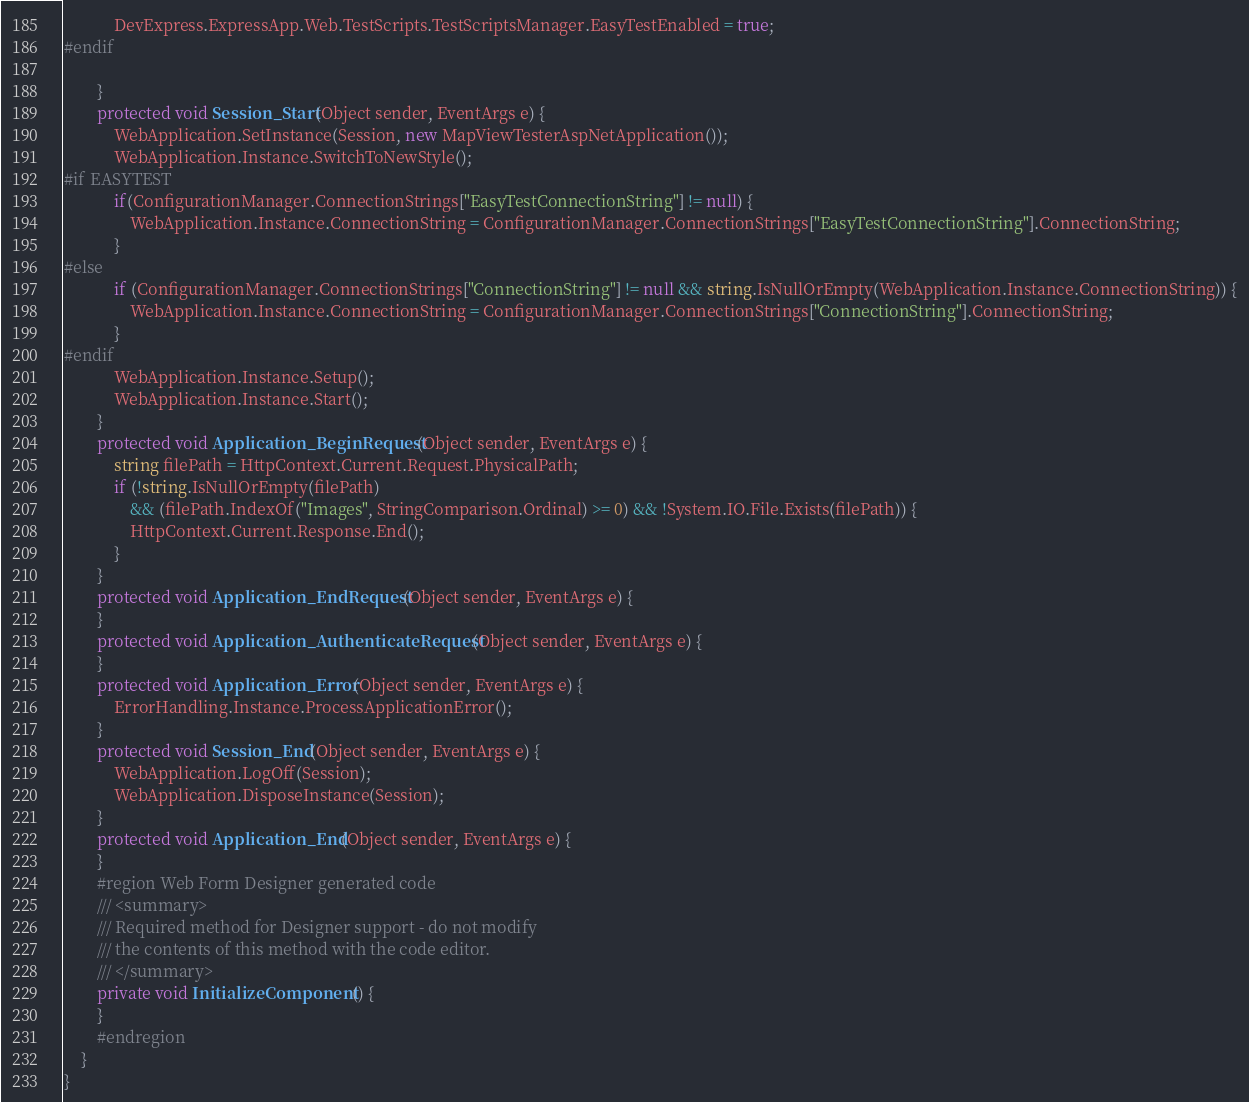<code> <loc_0><loc_0><loc_500><loc_500><_C#_>			DevExpress.ExpressApp.Web.TestScripts.TestScriptsManager.EasyTestEnabled = true;
#endif

        }
        protected void Session_Start(Object sender, EventArgs e) {
            WebApplication.SetInstance(Session, new MapViewTesterAspNetApplication());
            WebApplication.Instance.SwitchToNewStyle();
#if EASYTEST
			if(ConfigurationManager.ConnectionStrings["EasyTestConnectionString"] != null) {
				WebApplication.Instance.ConnectionString = ConfigurationManager.ConnectionStrings["EasyTestConnectionString"].ConnectionString;
			}
#else
            if (ConfigurationManager.ConnectionStrings["ConnectionString"] != null && string.IsNullOrEmpty(WebApplication.Instance.ConnectionString)) {
                WebApplication.Instance.ConnectionString = ConfigurationManager.ConnectionStrings["ConnectionString"].ConnectionString;
            }
#endif
            WebApplication.Instance.Setup();
            WebApplication.Instance.Start();
        }
        protected void Application_BeginRequest(Object sender, EventArgs e) {
            string filePath = HttpContext.Current.Request.PhysicalPath;
            if (!string.IsNullOrEmpty(filePath)
                && (filePath.IndexOf("Images", StringComparison.Ordinal) >= 0) && !System.IO.File.Exists(filePath)) {
                HttpContext.Current.Response.End();
            }
        }
        protected void Application_EndRequest(Object sender, EventArgs e) {
        }
        protected void Application_AuthenticateRequest(Object sender, EventArgs e) {
        }
        protected void Application_Error(Object sender, EventArgs e) {
            ErrorHandling.Instance.ProcessApplicationError();
        }
        protected void Session_End(Object sender, EventArgs e) {
            WebApplication.LogOff(Session);
            WebApplication.DisposeInstance(Session);
        }
        protected void Application_End(Object sender, EventArgs e) {
        }
        #region Web Form Designer generated code
        /// <summary>
        /// Required method for Designer support - do not modify
        /// the contents of this method with the code editor.
        /// </summary>
        private void InitializeComponent() {
        }
        #endregion
    }
}
</code> 